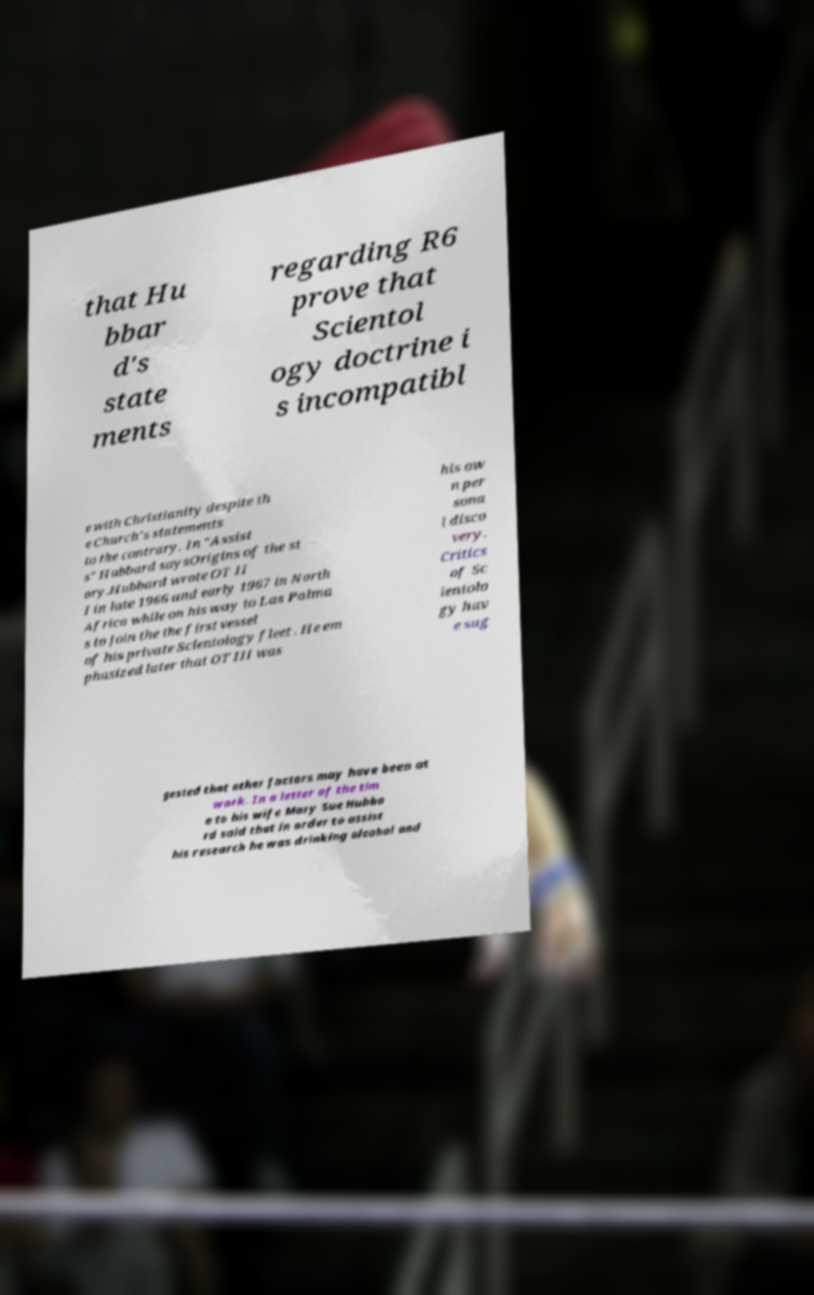Please identify and transcribe the text found in this image. that Hu bbar d's state ments regarding R6 prove that Scientol ogy doctrine i s incompatibl e with Christianity despite th e Church's statements to the contrary. In "Assist s" Hubbard saysOrigins of the st ory.Hubbard wrote OT II I in late 1966 and early 1967 in North Africa while on his way to Las Palma s to join the the first vessel of his private Scientology fleet . He em phasized later that OT III was his ow n per sona l disco very. Critics of Sc ientolo gy hav e sug gested that other factors may have been at work. In a letter of the tim e to his wife Mary Sue Hubba rd said that in order to assist his research he was drinking alcohol and 